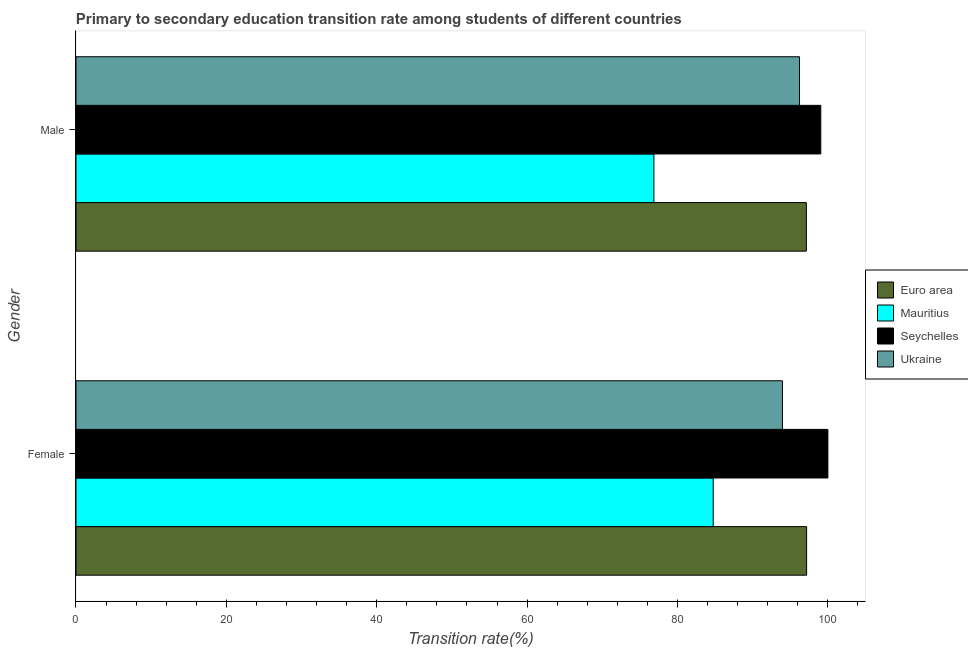How many groups of bars are there?
Keep it short and to the point. 2. Are the number of bars on each tick of the Y-axis equal?
Ensure brevity in your answer.  Yes. How many bars are there on the 2nd tick from the top?
Offer a terse response. 4. What is the transition rate among male students in Seychelles?
Provide a short and direct response. 99.05. Across all countries, what is the minimum transition rate among female students?
Make the answer very short. 84.75. In which country was the transition rate among female students maximum?
Your answer should be compact. Seychelles. In which country was the transition rate among female students minimum?
Offer a terse response. Mauritius. What is the total transition rate among female students in the graph?
Give a very brief answer. 375.88. What is the difference between the transition rate among male students in Euro area and that in Mauritius?
Provide a succinct answer. 20.28. What is the difference between the transition rate among male students in Seychelles and the transition rate among female students in Euro area?
Make the answer very short. 1.88. What is the average transition rate among female students per country?
Your response must be concise. 93.97. What is the difference between the transition rate among female students and transition rate among male students in Ukraine?
Keep it short and to the point. -2.27. In how many countries, is the transition rate among male students greater than 92 %?
Make the answer very short. 3. What is the ratio of the transition rate among female students in Seychelles to that in Ukraine?
Provide a short and direct response. 1.06. What does the 3rd bar from the top in Male represents?
Provide a succinct answer. Mauritius. How many bars are there?
Provide a succinct answer. 8. Are all the bars in the graph horizontal?
Give a very brief answer. Yes. Are the values on the major ticks of X-axis written in scientific E-notation?
Provide a succinct answer. No. Does the graph contain grids?
Your response must be concise. No. How are the legend labels stacked?
Offer a terse response. Vertical. What is the title of the graph?
Your response must be concise. Primary to secondary education transition rate among students of different countries. Does "Bosnia and Herzegovina" appear as one of the legend labels in the graph?
Your answer should be compact. No. What is the label or title of the X-axis?
Provide a succinct answer. Transition rate(%). What is the Transition rate(%) of Euro area in Female?
Offer a very short reply. 97.17. What is the Transition rate(%) of Mauritius in Female?
Your response must be concise. 84.75. What is the Transition rate(%) of Seychelles in Female?
Make the answer very short. 100. What is the Transition rate(%) in Ukraine in Female?
Keep it short and to the point. 93.96. What is the Transition rate(%) of Euro area in Male?
Your answer should be compact. 97.14. What is the Transition rate(%) in Mauritius in Male?
Offer a terse response. 76.86. What is the Transition rate(%) in Seychelles in Male?
Your response must be concise. 99.05. What is the Transition rate(%) in Ukraine in Male?
Your response must be concise. 96.23. Across all Gender, what is the maximum Transition rate(%) of Euro area?
Your response must be concise. 97.17. Across all Gender, what is the maximum Transition rate(%) of Mauritius?
Your answer should be very brief. 84.75. Across all Gender, what is the maximum Transition rate(%) in Ukraine?
Keep it short and to the point. 96.23. Across all Gender, what is the minimum Transition rate(%) of Euro area?
Your response must be concise. 97.14. Across all Gender, what is the minimum Transition rate(%) in Mauritius?
Ensure brevity in your answer.  76.86. Across all Gender, what is the minimum Transition rate(%) in Seychelles?
Offer a terse response. 99.05. Across all Gender, what is the minimum Transition rate(%) of Ukraine?
Your answer should be compact. 93.96. What is the total Transition rate(%) of Euro area in the graph?
Your response must be concise. 194.31. What is the total Transition rate(%) in Mauritius in the graph?
Your response must be concise. 161.61. What is the total Transition rate(%) of Seychelles in the graph?
Your answer should be very brief. 199.05. What is the total Transition rate(%) in Ukraine in the graph?
Your answer should be very brief. 190.19. What is the difference between the Transition rate(%) in Euro area in Female and that in Male?
Offer a terse response. 0.03. What is the difference between the Transition rate(%) of Mauritius in Female and that in Male?
Your answer should be compact. 7.89. What is the difference between the Transition rate(%) in Seychelles in Female and that in Male?
Keep it short and to the point. 0.95. What is the difference between the Transition rate(%) of Ukraine in Female and that in Male?
Offer a terse response. -2.27. What is the difference between the Transition rate(%) in Euro area in Female and the Transition rate(%) in Mauritius in Male?
Give a very brief answer. 20.31. What is the difference between the Transition rate(%) of Euro area in Female and the Transition rate(%) of Seychelles in Male?
Ensure brevity in your answer.  -1.88. What is the difference between the Transition rate(%) of Euro area in Female and the Transition rate(%) of Ukraine in Male?
Your response must be concise. 0.94. What is the difference between the Transition rate(%) of Mauritius in Female and the Transition rate(%) of Seychelles in Male?
Offer a terse response. -14.31. What is the difference between the Transition rate(%) of Mauritius in Female and the Transition rate(%) of Ukraine in Male?
Keep it short and to the point. -11.48. What is the difference between the Transition rate(%) of Seychelles in Female and the Transition rate(%) of Ukraine in Male?
Keep it short and to the point. 3.77. What is the average Transition rate(%) in Euro area per Gender?
Your answer should be very brief. 97.15. What is the average Transition rate(%) in Mauritius per Gender?
Provide a succinct answer. 80.8. What is the average Transition rate(%) in Seychelles per Gender?
Offer a terse response. 99.53. What is the average Transition rate(%) of Ukraine per Gender?
Your answer should be very brief. 95.09. What is the difference between the Transition rate(%) in Euro area and Transition rate(%) in Mauritius in Female?
Make the answer very short. 12.42. What is the difference between the Transition rate(%) of Euro area and Transition rate(%) of Seychelles in Female?
Your answer should be compact. -2.83. What is the difference between the Transition rate(%) of Euro area and Transition rate(%) of Ukraine in Female?
Offer a terse response. 3.21. What is the difference between the Transition rate(%) in Mauritius and Transition rate(%) in Seychelles in Female?
Provide a succinct answer. -15.25. What is the difference between the Transition rate(%) in Mauritius and Transition rate(%) in Ukraine in Female?
Offer a very short reply. -9.21. What is the difference between the Transition rate(%) of Seychelles and Transition rate(%) of Ukraine in Female?
Offer a terse response. 6.04. What is the difference between the Transition rate(%) in Euro area and Transition rate(%) in Mauritius in Male?
Make the answer very short. 20.28. What is the difference between the Transition rate(%) in Euro area and Transition rate(%) in Seychelles in Male?
Your answer should be compact. -1.92. What is the difference between the Transition rate(%) in Euro area and Transition rate(%) in Ukraine in Male?
Provide a succinct answer. 0.91. What is the difference between the Transition rate(%) in Mauritius and Transition rate(%) in Seychelles in Male?
Make the answer very short. -22.19. What is the difference between the Transition rate(%) in Mauritius and Transition rate(%) in Ukraine in Male?
Provide a short and direct response. -19.37. What is the difference between the Transition rate(%) of Seychelles and Transition rate(%) of Ukraine in Male?
Ensure brevity in your answer.  2.83. What is the ratio of the Transition rate(%) of Euro area in Female to that in Male?
Your response must be concise. 1. What is the ratio of the Transition rate(%) in Mauritius in Female to that in Male?
Offer a terse response. 1.1. What is the ratio of the Transition rate(%) in Seychelles in Female to that in Male?
Your answer should be very brief. 1.01. What is the ratio of the Transition rate(%) of Ukraine in Female to that in Male?
Ensure brevity in your answer.  0.98. What is the difference between the highest and the second highest Transition rate(%) of Euro area?
Offer a very short reply. 0.03. What is the difference between the highest and the second highest Transition rate(%) of Mauritius?
Your response must be concise. 7.89. What is the difference between the highest and the second highest Transition rate(%) of Seychelles?
Give a very brief answer. 0.95. What is the difference between the highest and the second highest Transition rate(%) of Ukraine?
Provide a short and direct response. 2.27. What is the difference between the highest and the lowest Transition rate(%) of Euro area?
Provide a short and direct response. 0.03. What is the difference between the highest and the lowest Transition rate(%) in Mauritius?
Keep it short and to the point. 7.89. What is the difference between the highest and the lowest Transition rate(%) of Seychelles?
Give a very brief answer. 0.95. What is the difference between the highest and the lowest Transition rate(%) in Ukraine?
Your response must be concise. 2.27. 